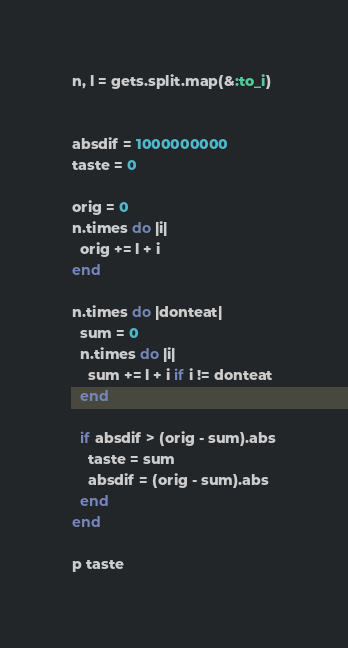<code> <loc_0><loc_0><loc_500><loc_500><_Ruby_>n, l = gets.split.map(&:to_i)


absdif = 1000000000
taste = 0

orig = 0
n.times do |i|
  orig += l + i
end

n.times do |donteat|
  sum = 0
  n.times do |i|
    sum += l + i if i != donteat
  end

  if absdif > (orig - sum).abs
    taste = sum
    absdif = (orig - sum).abs
  end
end

p taste
</code> 